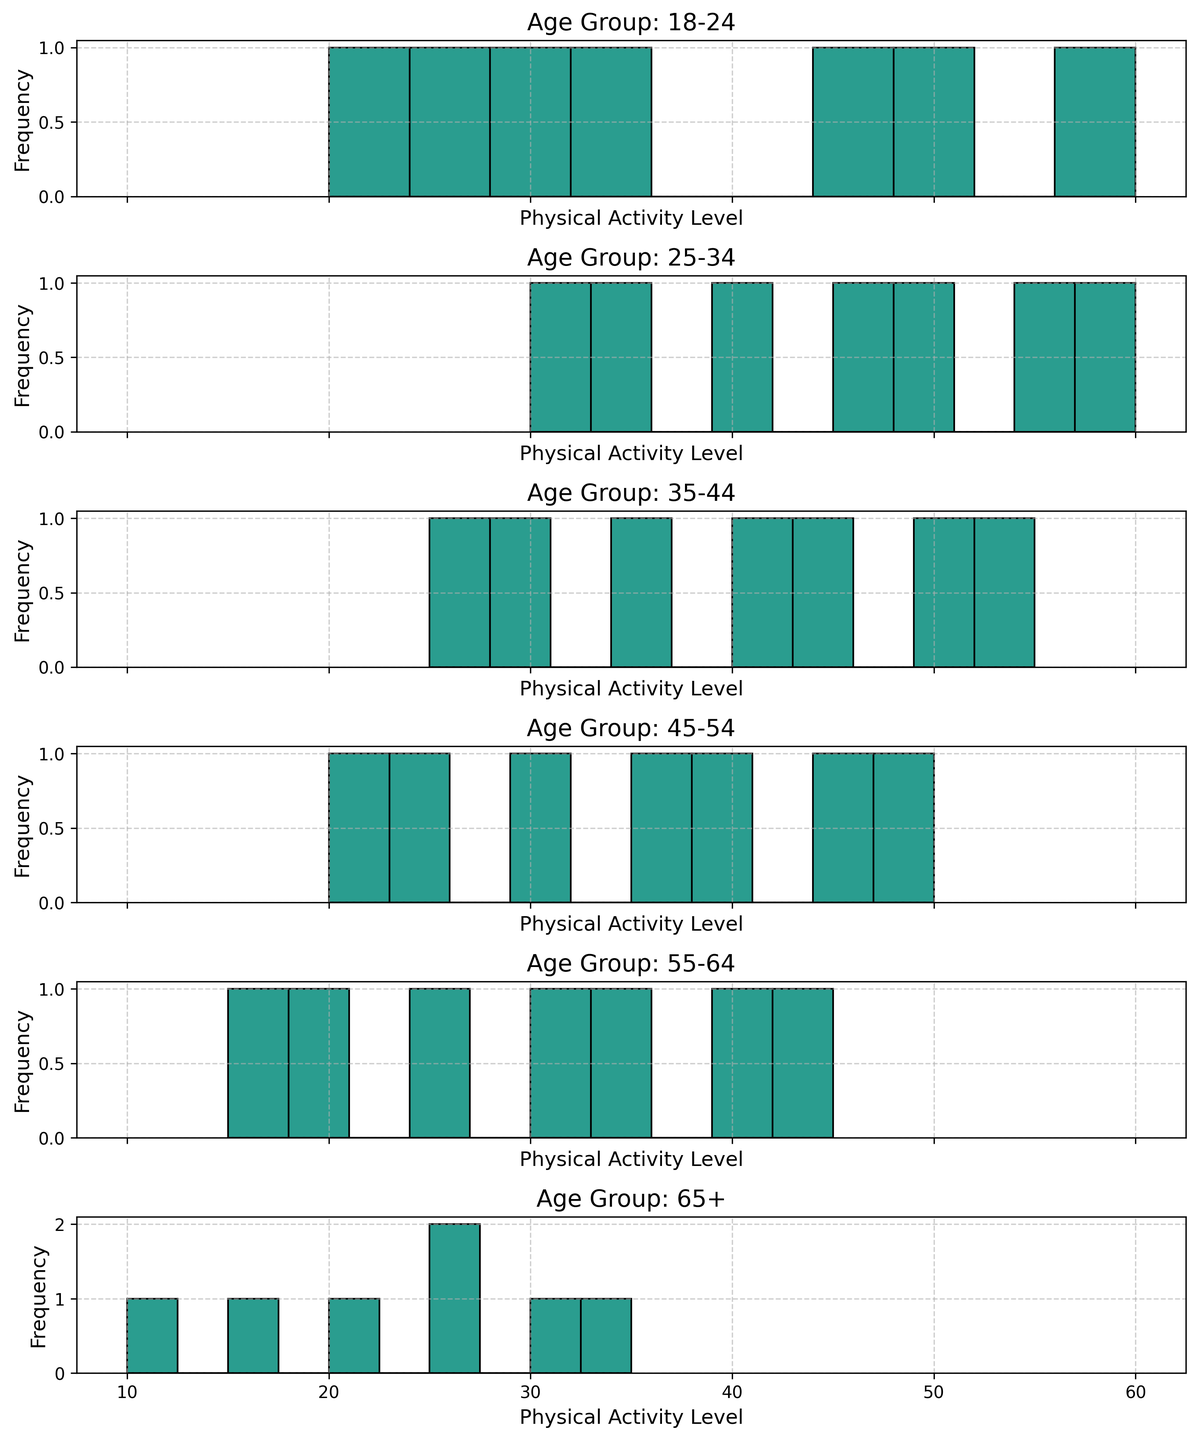What age group has the highest frequency of physical activity level at 30? Look at each histogram and identify the count of people with the physical activity level of 30. The age group 25-34 has a clearly higher bar at this level compared to other age groups.
Answer: 25-34 Which age group has more people with a physical activity level of 45, 35-44, or 45-54? Compare the height of the bar representing the physical activity level of 45 in the histograms of both age groups. The bar is taller in the 35-44 age group.
Answer: 35-44 What’s the average physical activity level of the 55-64 age group? The levels are [15, 25, 35, 20, 30, 40, 45]. Sum these values (15 + 25 + 35 + 20 + 30 + 40 + 45 = 210) and divide by the number of observations (7). 210 / 7 = 30.
Answer: 30 Which age group has the largest spread in physical activity levels? Identify the range (difference between maximum and minimum values) in each histogram. The largest difference is in the 18-24 group (60 - 20 = 40).
Answer: 18-24 What's the median physical activity level for the 45-54 age group? The levels are [20, 30, 40, 25, 35, 50, 45]. Sort these values [20, 25, 30, 35, 40, 45, 50]. The median is the middle value, which is 35.
Answer: 35 Which age group has the highest peak in their histogram data? Observe the height of the tallest bars across all histograms. The 18-24 age group has the highest peak around the physical activity level of 30.
Answer: 18-24 What’s the combined total count of people with physical activity levels between 20 and 40 in the 65+ age group? Count the frequencies for levels 20, 25, 30, and 35 in the 65+ histogram. The counts are: 20 (1), 25 (2), 30 (1), 35 (1). Sum these counts: 1 + 2 + 1 + 1 = 5.
Answer: 5 Which age group has the lowest range of physical activity levels? Identify the range (difference between maximum and minimum values) in each histogram. The smallest difference is in the 65+ group (35 - 10 = 25).
Answer: 65+ Between the age groups 25-34 and 35-44, which one has more participants with a physical activity level of 50? Compare the bars for the level 50 in both histograms. The 25-34 age group has a higher bar.
Answer: 25-34 